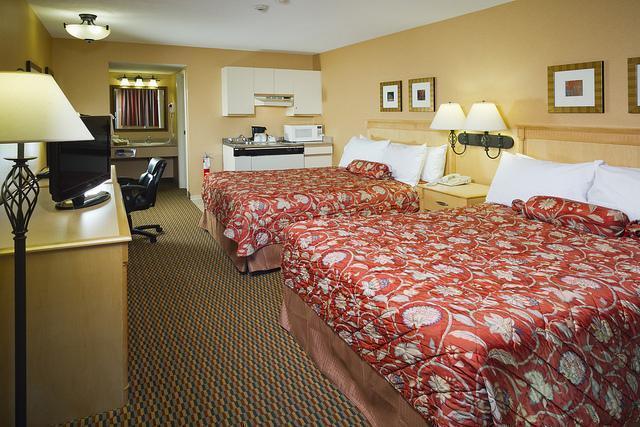Who would stay in this room?
Indicate the correct response by choosing from the four available options to answer the question.
Options: Resident, prisoner, maid, traveler. Traveler. 